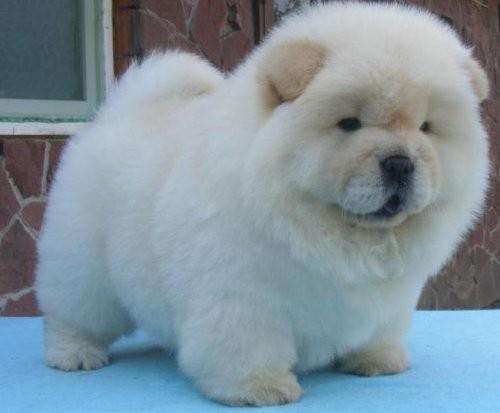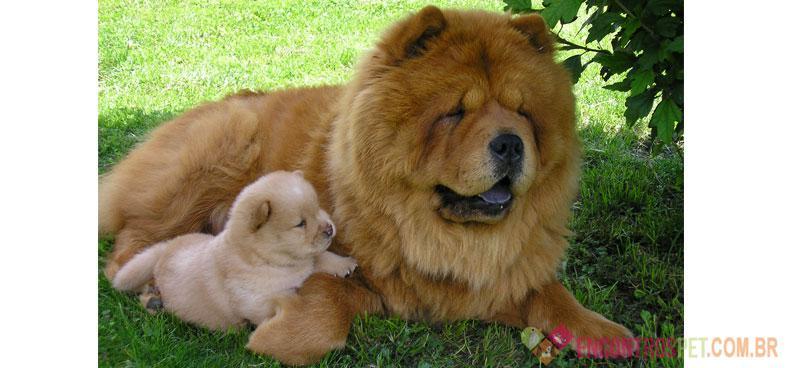The first image is the image on the left, the second image is the image on the right. Assess this claim about the two images: "A dog is laying in grass.". Correct or not? Answer yes or no. Yes. The first image is the image on the left, the second image is the image on the right. Evaluate the accuracy of this statement regarding the images: "The left and right image contains the same number of dogs with one being held in a woman's arms.". Is it true? Answer yes or no. No. 